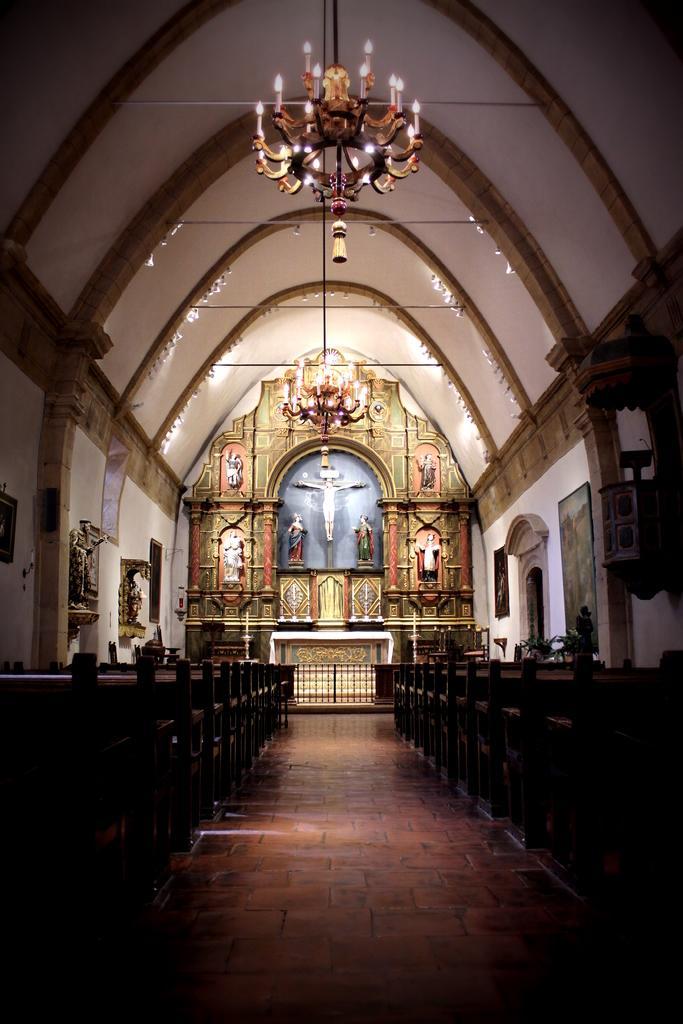Please provide a concise description of this image. In this image we can see an inside view of the building, in which we can see some statues. On the left and right side of the image we can see some benches placed on the ground and some photo frames on the wall. At the top of the image we can see a chandelier. 